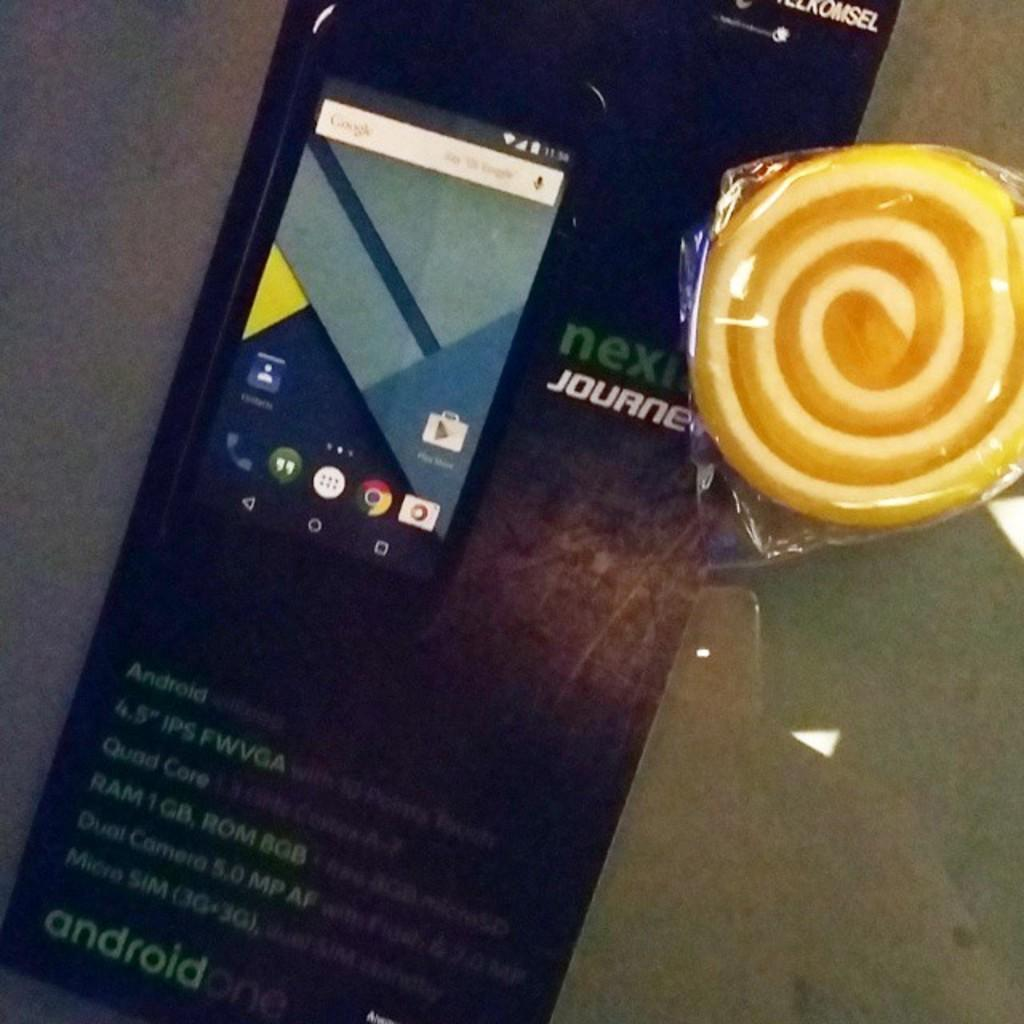<image>
Summarize the visual content of the image. The word journey is written on the phone beside the lolly. 